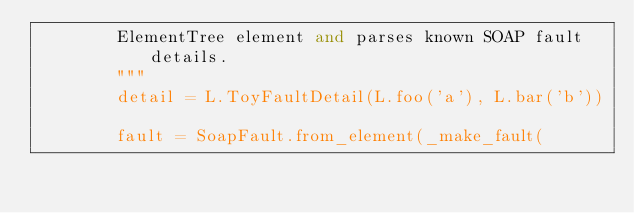<code> <loc_0><loc_0><loc_500><loc_500><_Python_>        ElementTree element and parses known SOAP fault details.
        """
        detail = L.ToyFaultDetail(L.foo('a'), L.bar('b'))

        fault = SoapFault.from_element(_make_fault(</code> 